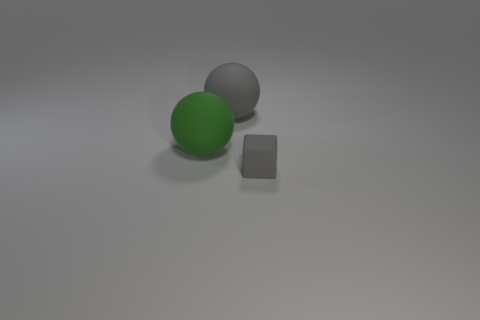What shape is the gray object to the left of the tiny thing?
Keep it short and to the point. Sphere. What material is the sphere left of the gray matte object that is to the left of the gray block?
Keep it short and to the point. Rubber. Are there more gray matte spheres in front of the large gray matte ball than tiny gray rubber cubes?
Give a very brief answer. No. What number of other objects are there of the same color as the block?
Provide a succinct answer. 1. The green object that is the same size as the gray rubber sphere is what shape?
Your response must be concise. Sphere. There is a gray object that is in front of the gray rubber thing that is behind the gray rubber block; what number of green matte things are behind it?
Offer a terse response. 1. How many shiny objects are either gray cubes or brown cubes?
Offer a terse response. 0. What is the color of the thing that is both in front of the gray sphere and to the right of the green sphere?
Keep it short and to the point. Gray. Is the size of the rubber thing behind the green thing the same as the tiny gray rubber thing?
Your response must be concise. No. What number of objects are matte objects that are to the right of the large gray sphere or yellow matte balls?
Your response must be concise. 1. 